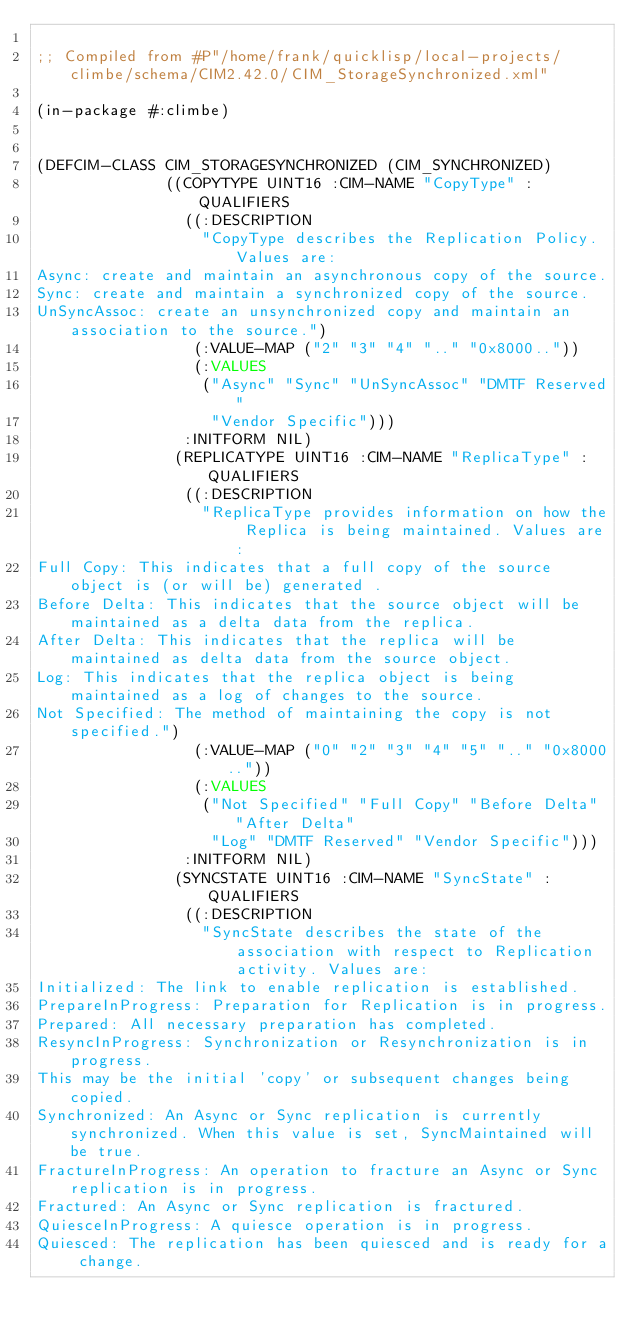<code> <loc_0><loc_0><loc_500><loc_500><_Lisp_>
;; Compiled from #P"/home/frank/quicklisp/local-projects/climbe/schema/CIM2.42.0/CIM_StorageSynchronized.xml"

(in-package #:climbe)


(DEFCIM-CLASS CIM_STORAGESYNCHRONIZED (CIM_SYNCHRONIZED)
              ((COPYTYPE UINT16 :CIM-NAME "CopyType" :QUALIFIERS
                ((:DESCRIPTION
                  "CopyType describes the Replication Policy. Values are: 
Async: create and maintain an asynchronous copy of the source. 
Sync: create and maintain a synchronized copy of the source. 
UnSyncAssoc: create an unsynchronized copy and maintain an association to the source.")
                 (:VALUE-MAP ("2" "3" "4" ".." "0x8000.."))
                 (:VALUES
                  ("Async" "Sync" "UnSyncAssoc" "DMTF Reserved"
                   "Vendor Specific")))
                :INITFORM NIL)
               (REPLICATYPE UINT16 :CIM-NAME "ReplicaType" :QUALIFIERS
                ((:DESCRIPTION
                  "ReplicaType provides information on how the Replica is being maintained. Values are: 
Full Copy: This indicates that a full copy of the source object is (or will be) generated . 
Before Delta: This indicates that the source object will be maintained as a delta data from the replica. 
After Delta: This indicates that the replica will be maintained as delta data from the source object. 
Log: This indicates that the replica object is being maintained as a log of changes to the source. 
Not Specified: The method of maintaining the copy is not specified.")
                 (:VALUE-MAP ("0" "2" "3" "4" "5" ".." "0x8000.."))
                 (:VALUES
                  ("Not Specified" "Full Copy" "Before Delta" "After Delta"
                   "Log" "DMTF Reserved" "Vendor Specific")))
                :INITFORM NIL)
               (SYNCSTATE UINT16 :CIM-NAME "SyncState" :QUALIFIERS
                ((:DESCRIPTION
                  "SyncState describes the state of the association with respect to Replication activity. Values are: 
Initialized: The link to enable replication is established. 
PrepareInProgress: Preparation for Replication is in progress. 
Prepared: All necessary preparation has completed. 
ResyncInProgress: Synchronization or Resynchronization is in progress. 
This may be the initial 'copy' or subsequent changes being copied. 
Synchronized: An Async or Sync replication is currently synchronized. When this value is set, SyncMaintained will be true. 
FractureInProgress: An operation to fracture an Async or Sync replication is in progress. 
Fractured: An Async or Sync replication is fractured. 
QuiesceInProgress: A quiesce operation is in progress. 
Quiesced: The replication has been quiesced and is ready for a change. </code> 